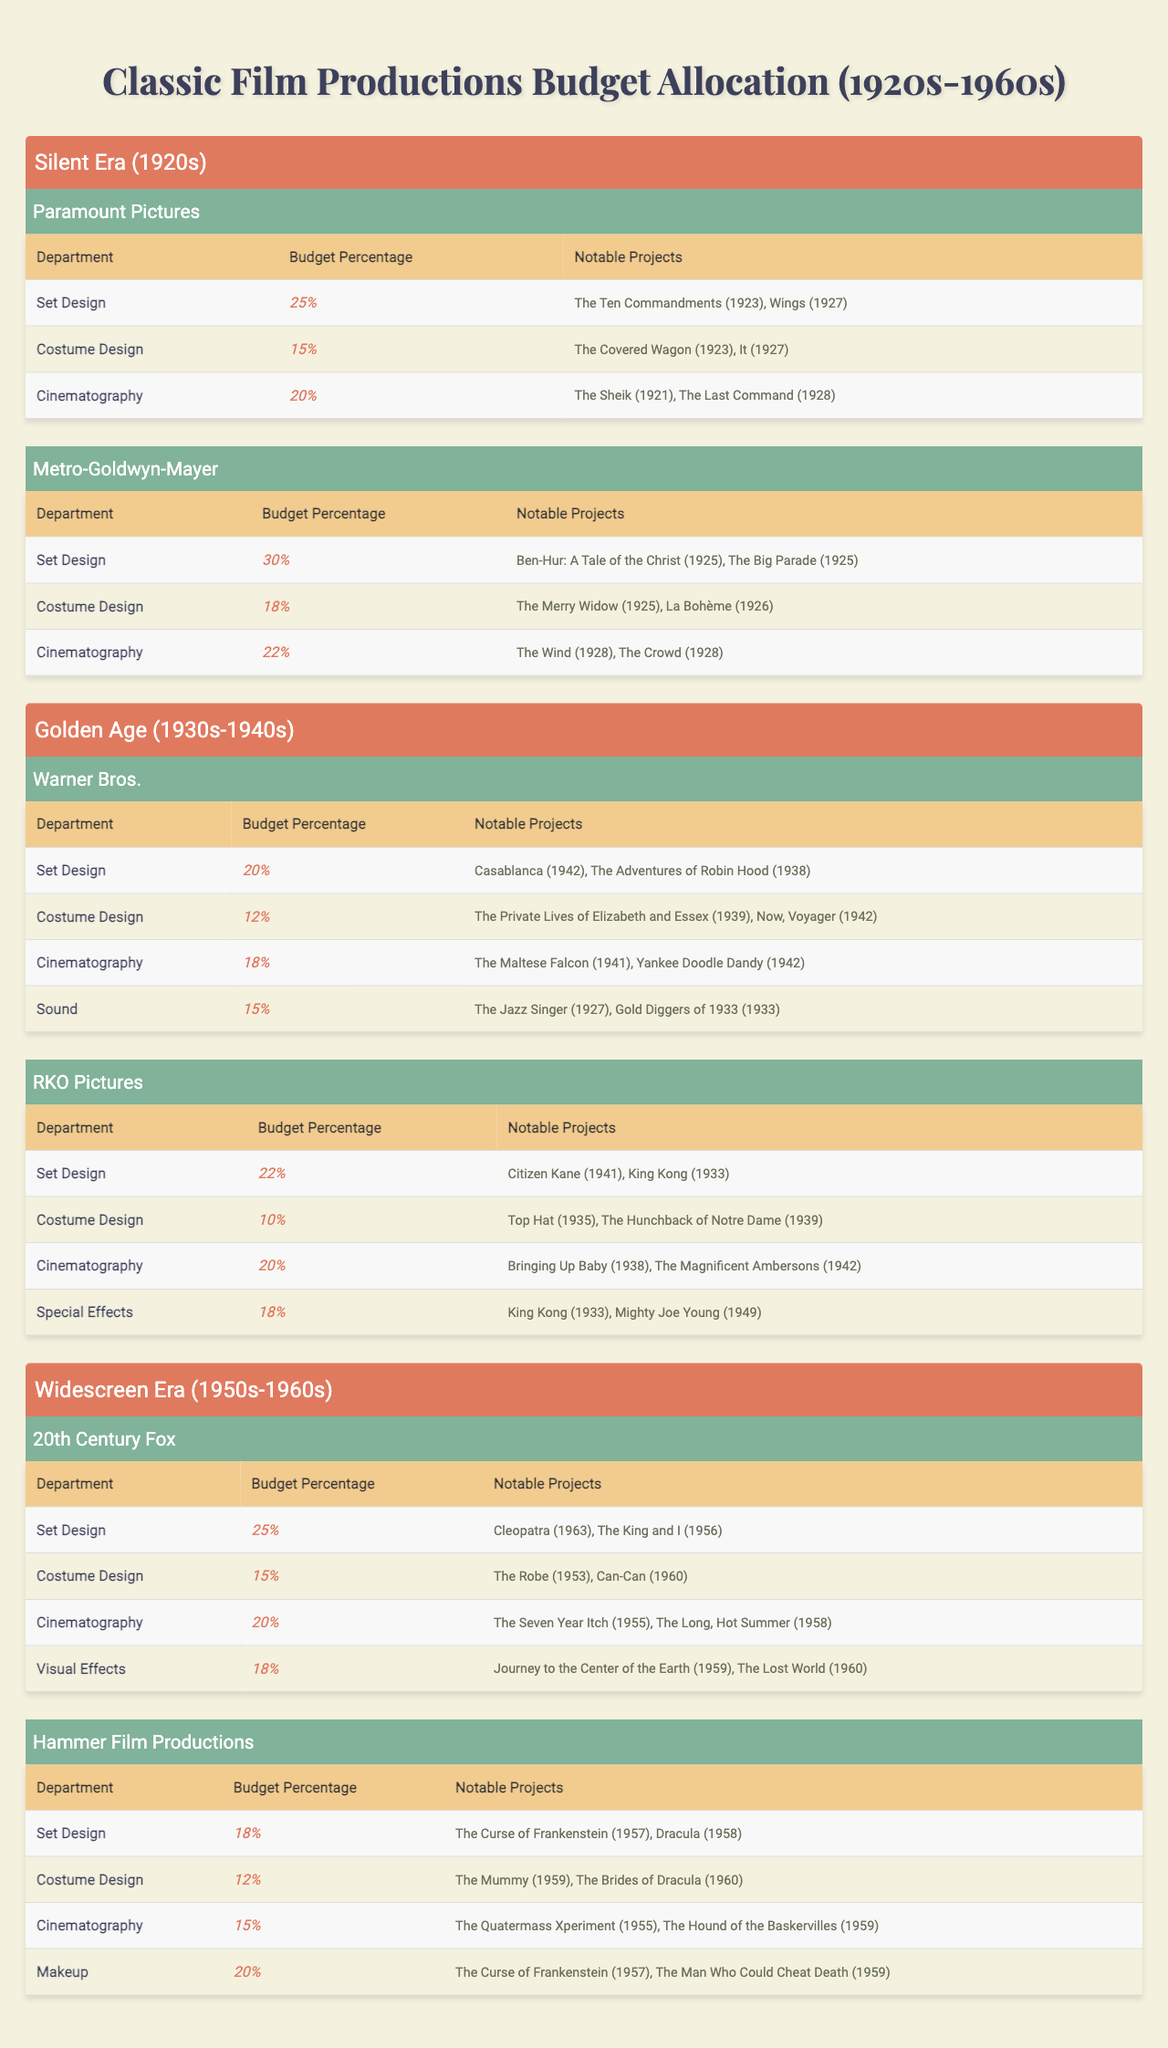What is the highest budget percentage for Set Design in the Silent Era? Looking at the Silent Era, the studio with the highest budget percentage for Set Design is Metro-Goldwyn-Mayer, with a budget percentage of 30%.
Answer: 30% Which department at Warner Bros. had the lowest budget allocation? At Warner Bros., the department with the lowest budget allocation is Costume Design, with a budget percentage of 12%.
Answer: 12% How much higher is the budget percentage for Cinematography at RKO Pictures compared to Costume Design? At RKO Pictures, the budget percentage for Cinematography is 20% and for Costume Design is 10%. The difference is 20% - 10% = 10%.
Answer: 10% True or False: Hammer Film Productions allocated the same budget percentage for Costume Design and Set Design. Hammer Film Productions allocated 12% for Costume Design and 18% for Set Design. Therefore, this statement is false.
Answer: False What is the total budget percentage allocated to Sound and Cinematography at Warner Bros.? Warner Bros. allocated 18% to Cinematography and 15% to Sound. The total is 18% + 15% = 33%.
Answer: 33% Which studio in the Widescreen Era had the highest budget for Makeup? The studio with the highest budget for Makeup in the Widescreen Era is Hammer Film Productions, which allocated 20% to that department.
Answer: 20% Across all eras, what is the average budget percentage allocated to Costume Design? The budget percentages for Costume Design across the eras are 15%, 12%, and 15% (from the Silent Era, Golden Age, and Widescreen Era respectively). The average is (15 + 12 + 15) / 3 = 14%.
Answer: 14% How many notable projects are associated with the Set Design department at 20th Century Fox? The Set Design department at 20th Century Fox has two notable projects listed: "Cleopatra (1963)" and "The King and I (1956)". So, there are two notable projects.
Answer: 2 What is the total budget percentage allocated to all departments by Metro-Goldwyn-Mayer? For Metro-Goldwyn-Mayer, the allocations are 30% (Set Design) + 18% (Costume Design) + 22% (Cinematography) = 70%.
Answer: 70% Which era saw the highest average budget percentage for Visual Effects? The Visual Effects department appears only in the Widescreen Era with a budget percentage of 18%. Thus, it has the highest average since it is the only value available.
Answer: 18% 